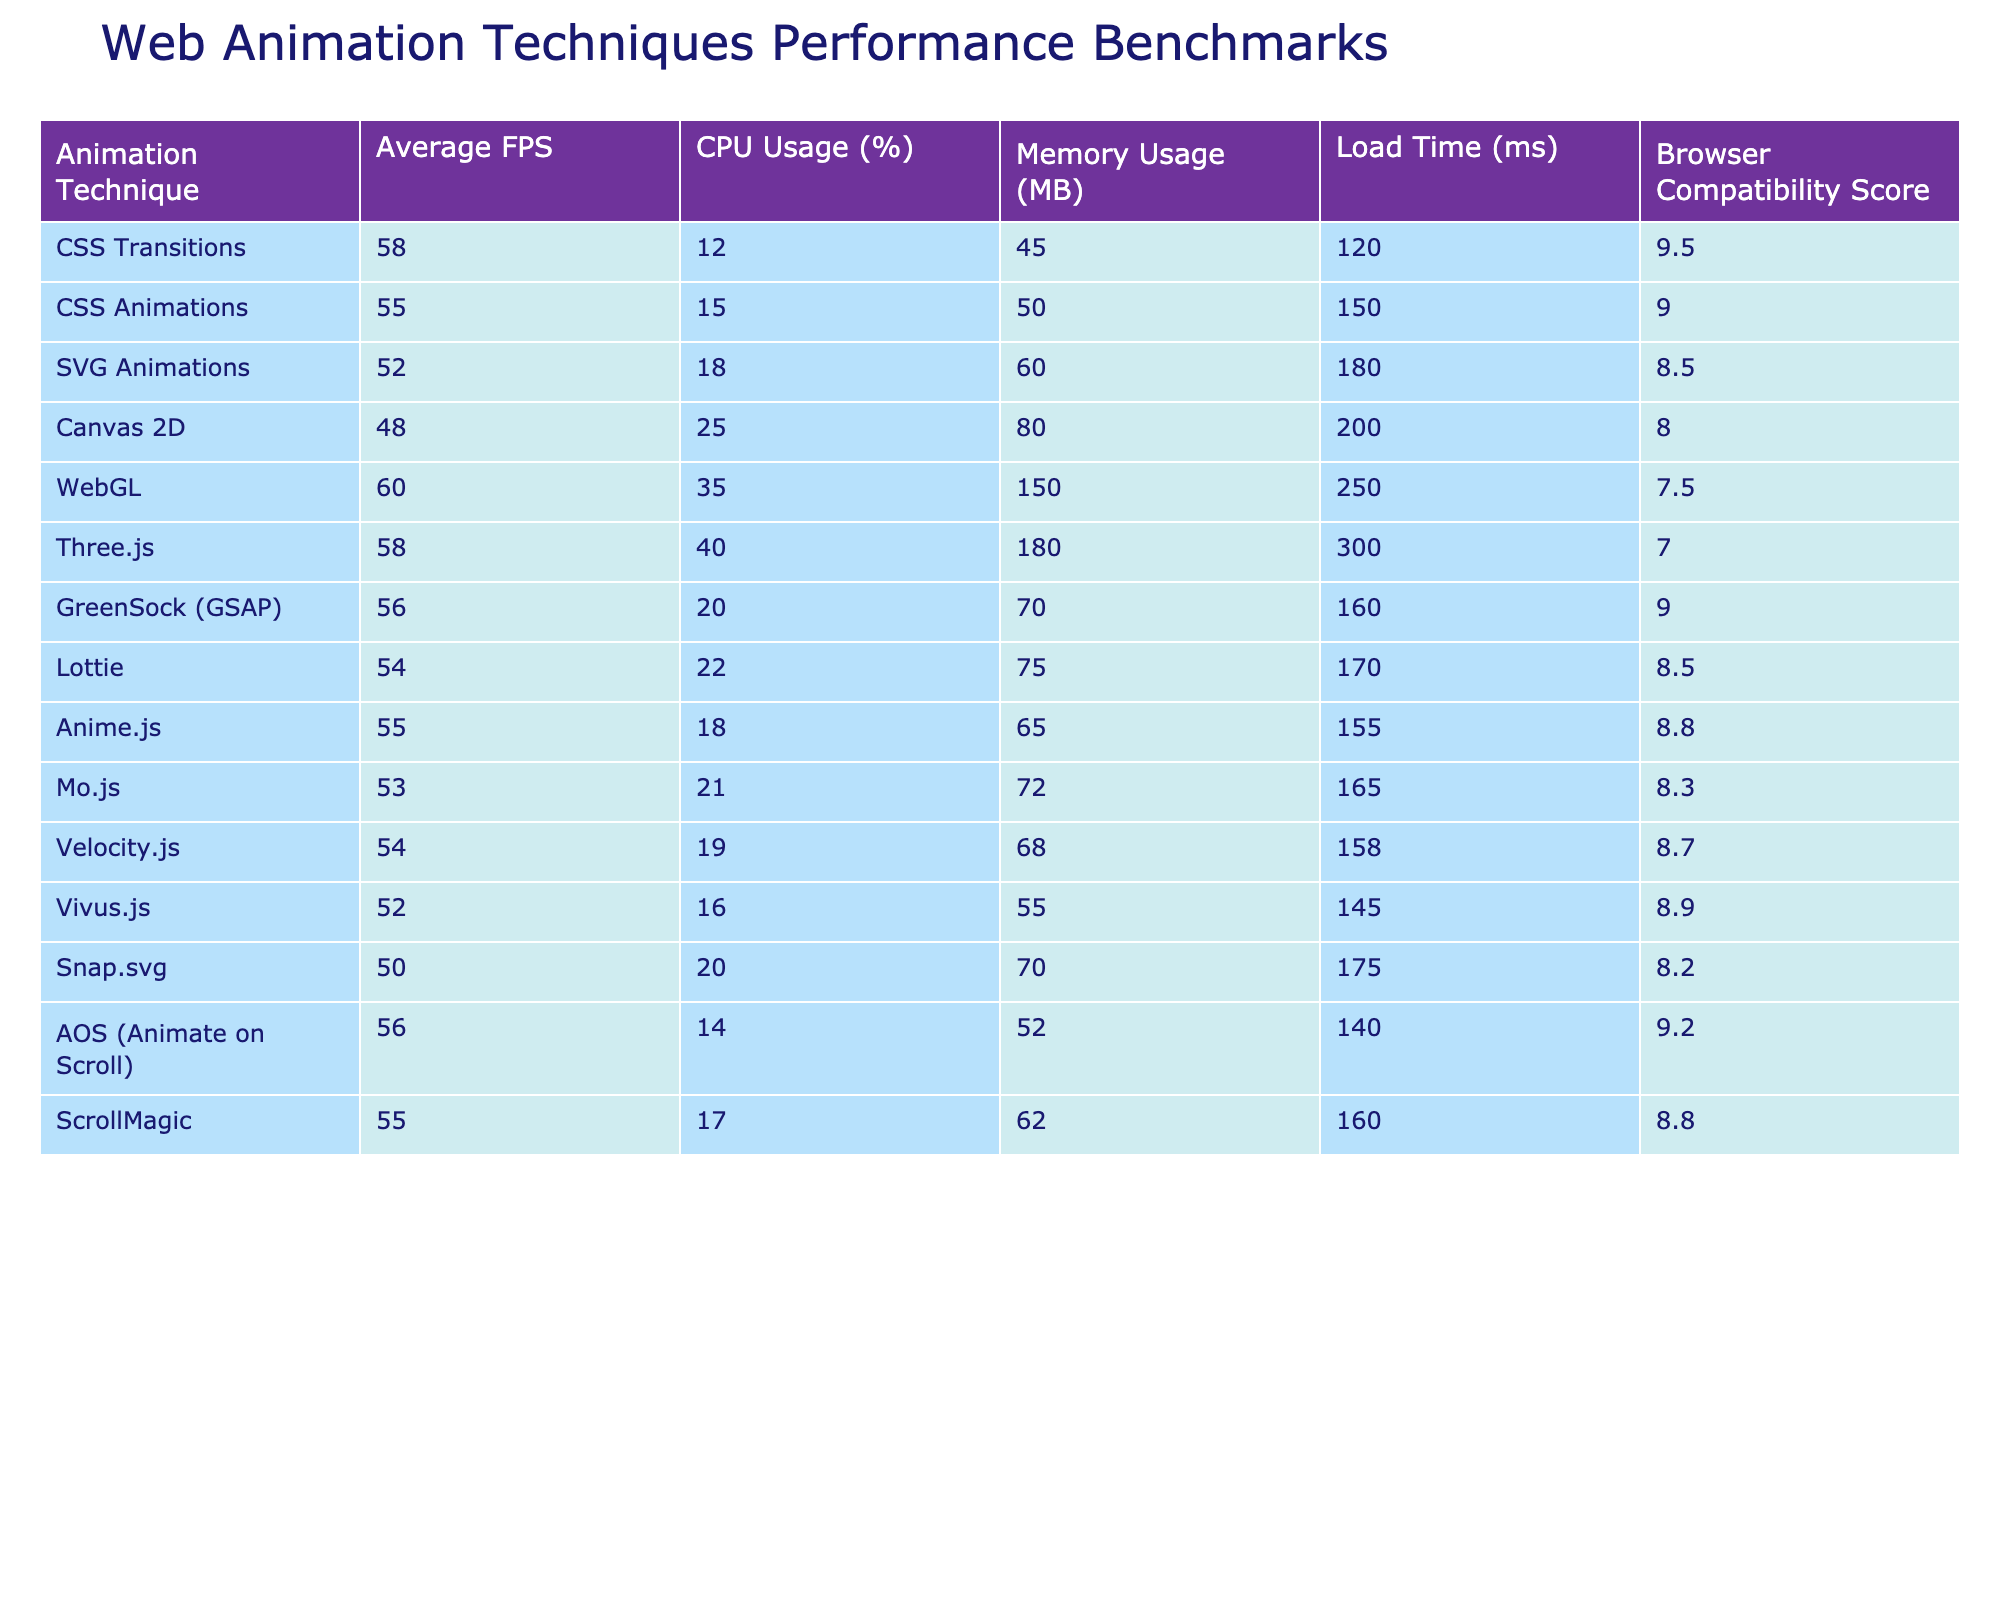What is the average FPS for CSS Animations? The table shows that the average FPS for CSS Animations is listed directly under the "Average FPS" column. That value is 55.
Answer: 55 Which animation technique has the highest CPU usage? By examining the "CPU Usage (%)" column, WebGL has the highest CPU usage at 35%.
Answer: WebGL How much memory does Mo.js use? The memory usage for Mo.js can be found in the "Memory Usage (MB)" column, where the value is 72 MB.
Answer: 72 MB What is the load time for Lottie animations? The "Load Time (ms)" column lists Lottie’s load time directly as 170 milliseconds.
Answer: 170 ms Is GreenSock (GSAP) more efficient in CPU usage compared to Canvas 2D? Comparing the CPU usage values, GSAP uses 20% while Canvas 2D uses 25%, so GSAP is indeed more efficient by 5%.
Answer: Yes Calculate the average load time of CSS Transitions and AOS (Animate on Scroll). First, we find the load times: CSS Transitions is 120 ms and AOS is 140 ms. Then, we sum these values: 120 + 140 = 260 ms. Finally, we divide by 2 to get the average: 260 / 2 = 130 ms.
Answer: 130 ms Which techniques have a compatibility score lower than 8.5? Analyzing the "Browser Compatibility Score" column, the techniques with scores below 8.5 are Canvas 2D, WebGL, Three.js, and Mo.js.
Answer: Canvas 2D, WebGL, Three.js, Mo.js How does the average FPS of CSS Transitions compare to that of SVG Animations? The FPS for CSS Transitions is 58, while for SVG Animations it is 52. The difference is 58 - 52 = 6 FPS, indicating that CSS Transitions performs better.
Answer: 6 FPS What is the combined memory usage of both GreenSock (GSAP) and Lottie? The memory usage for GSAP is 70 MB and for Lottie it is 75 MB. Combined, this is 70 + 75 = 145 MB total memory usage.
Answer: 145 MB Which offers better performance in terms of FPS, CSS Animations or Anime.js? CSS Animations have an FPS of 55, while Anime.js has an FPS of 55 as well. They perform equally in terms of frames per second.
Answer: They are equal 